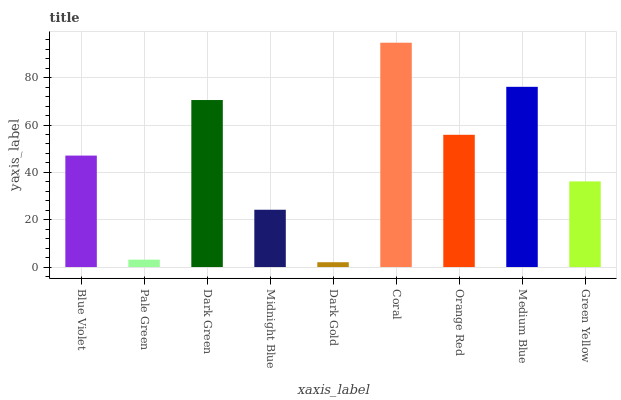Is Dark Gold the minimum?
Answer yes or no. Yes. Is Coral the maximum?
Answer yes or no. Yes. Is Pale Green the minimum?
Answer yes or no. No. Is Pale Green the maximum?
Answer yes or no. No. Is Blue Violet greater than Pale Green?
Answer yes or no. Yes. Is Pale Green less than Blue Violet?
Answer yes or no. Yes. Is Pale Green greater than Blue Violet?
Answer yes or no. No. Is Blue Violet less than Pale Green?
Answer yes or no. No. Is Blue Violet the high median?
Answer yes or no. Yes. Is Blue Violet the low median?
Answer yes or no. Yes. Is Medium Blue the high median?
Answer yes or no. No. Is Midnight Blue the low median?
Answer yes or no. No. 